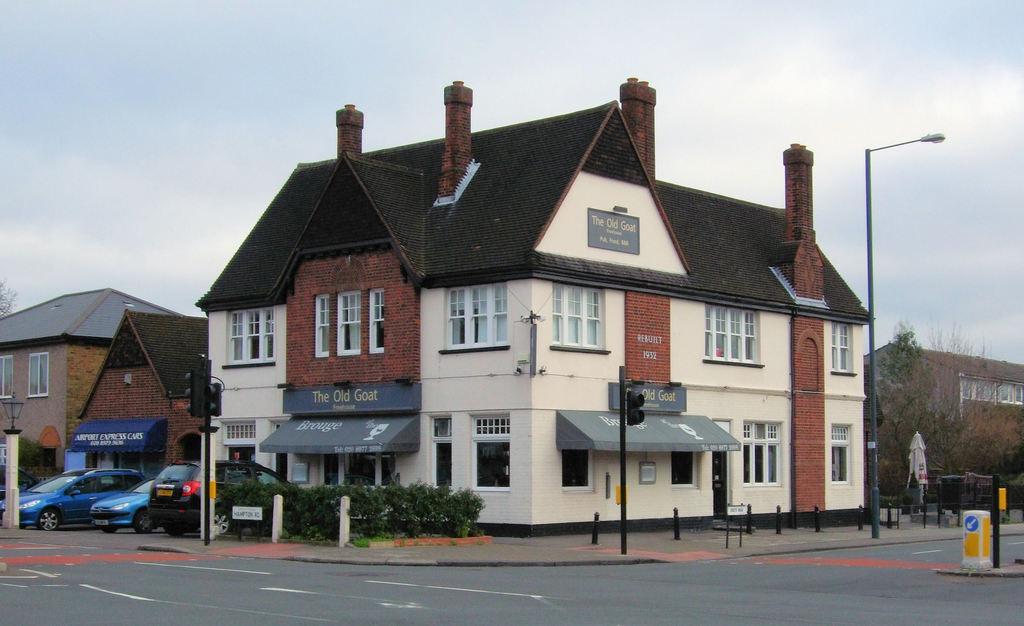Describe this image in one or two sentences. In the picture I can see few buildings which has few vehicles and trees in front of it and there are few other trees and a building in the right corner. 